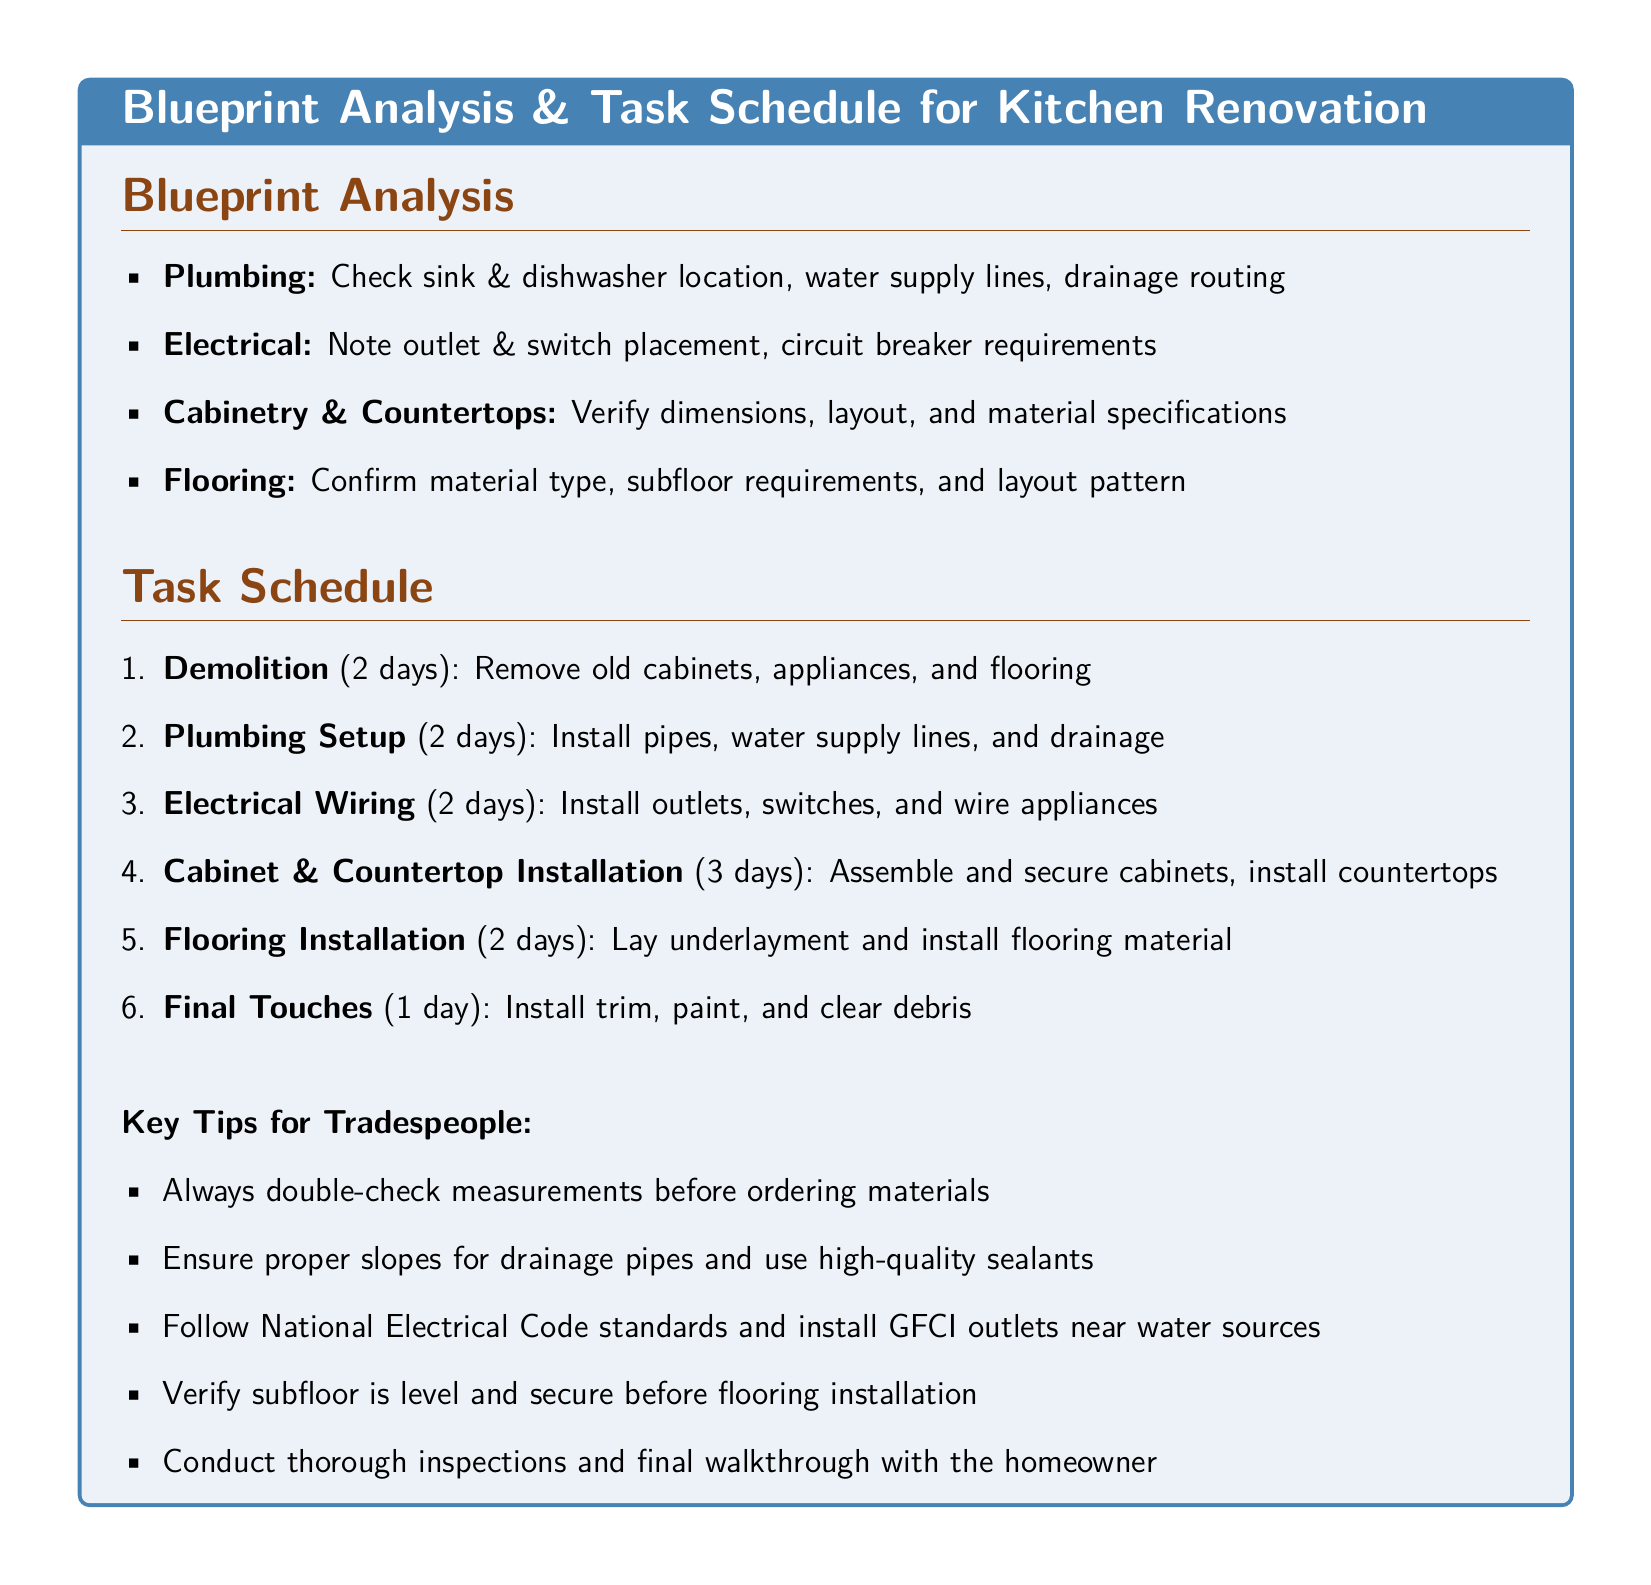What is the first task in the schedule? The first task in the schedule is listed as "Demolition," which is the starting point for the renovation process.
Answer: Demolition How many days are allocated for flooring installation? The document specifies that flooring installation will take 2 days, which is essential for the timely completion of the project.
Answer: 2 days What material is checked during the plumbing analysis? The plumbing analysis includes checking the sink and dishwasher location, as well as water supply lines and drainage routing.
Answer: Water supply lines How many days are estimated for cabinet and countertop installation? The estimated time for cabinet and countertop installation is an important part of the overall project timeline, listed as 3 days in the schedule.
Answer: 3 days What is one key tip for tradespeople regarding measurements? A key tip mentioned in the document highlights the importance of double-checking measurements to prevent errors in material ordering and installation.
Answer: Double-check measurements What is included in the final touches? The final touches involve installing trim, painting, and clearing debris, which are essential for completing the renovation elegantly.
Answer: Install trim Which electrical safety standard is mentioned? The document emphasizes the necessity of following National Electrical Code standards, particularly for safety in kitchen renovations.
Answer: National Electrical Code What is checked regarding cabinetry? The analysis for cabinetry includes verifying dimensions, layout, and material specifications, which ensures proper fit and functionality.
Answer: Dimensions How many total tasks are in the schedule? The task schedule includes a total of 6 tasks, guiding the workflow throughout the renovation project.
Answer: 6 tasks 